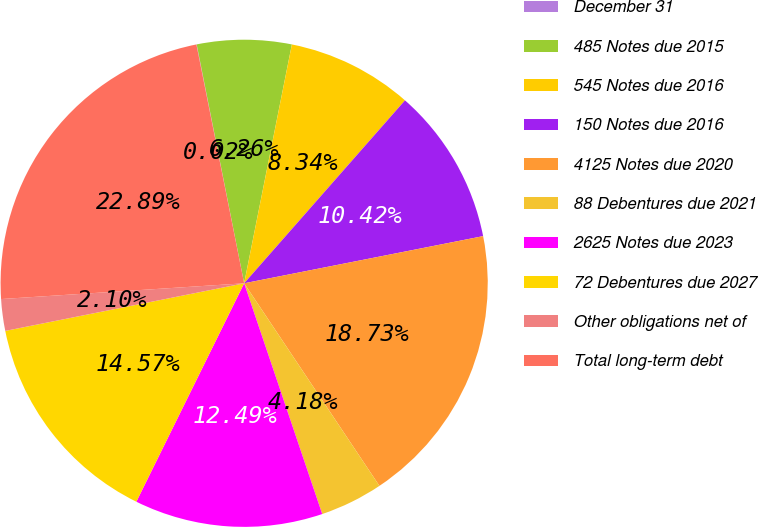Convert chart to OTSL. <chart><loc_0><loc_0><loc_500><loc_500><pie_chart><fcel>December 31<fcel>485 Notes due 2015<fcel>545 Notes due 2016<fcel>150 Notes due 2016<fcel>4125 Notes due 2020<fcel>88 Debentures due 2021<fcel>2625 Notes due 2023<fcel>72 Debentures due 2027<fcel>Other obligations net of<fcel>Total long-term debt<nl><fcel>0.02%<fcel>6.26%<fcel>8.34%<fcel>10.42%<fcel>18.73%<fcel>4.18%<fcel>12.49%<fcel>14.57%<fcel>2.1%<fcel>22.89%<nl></chart> 